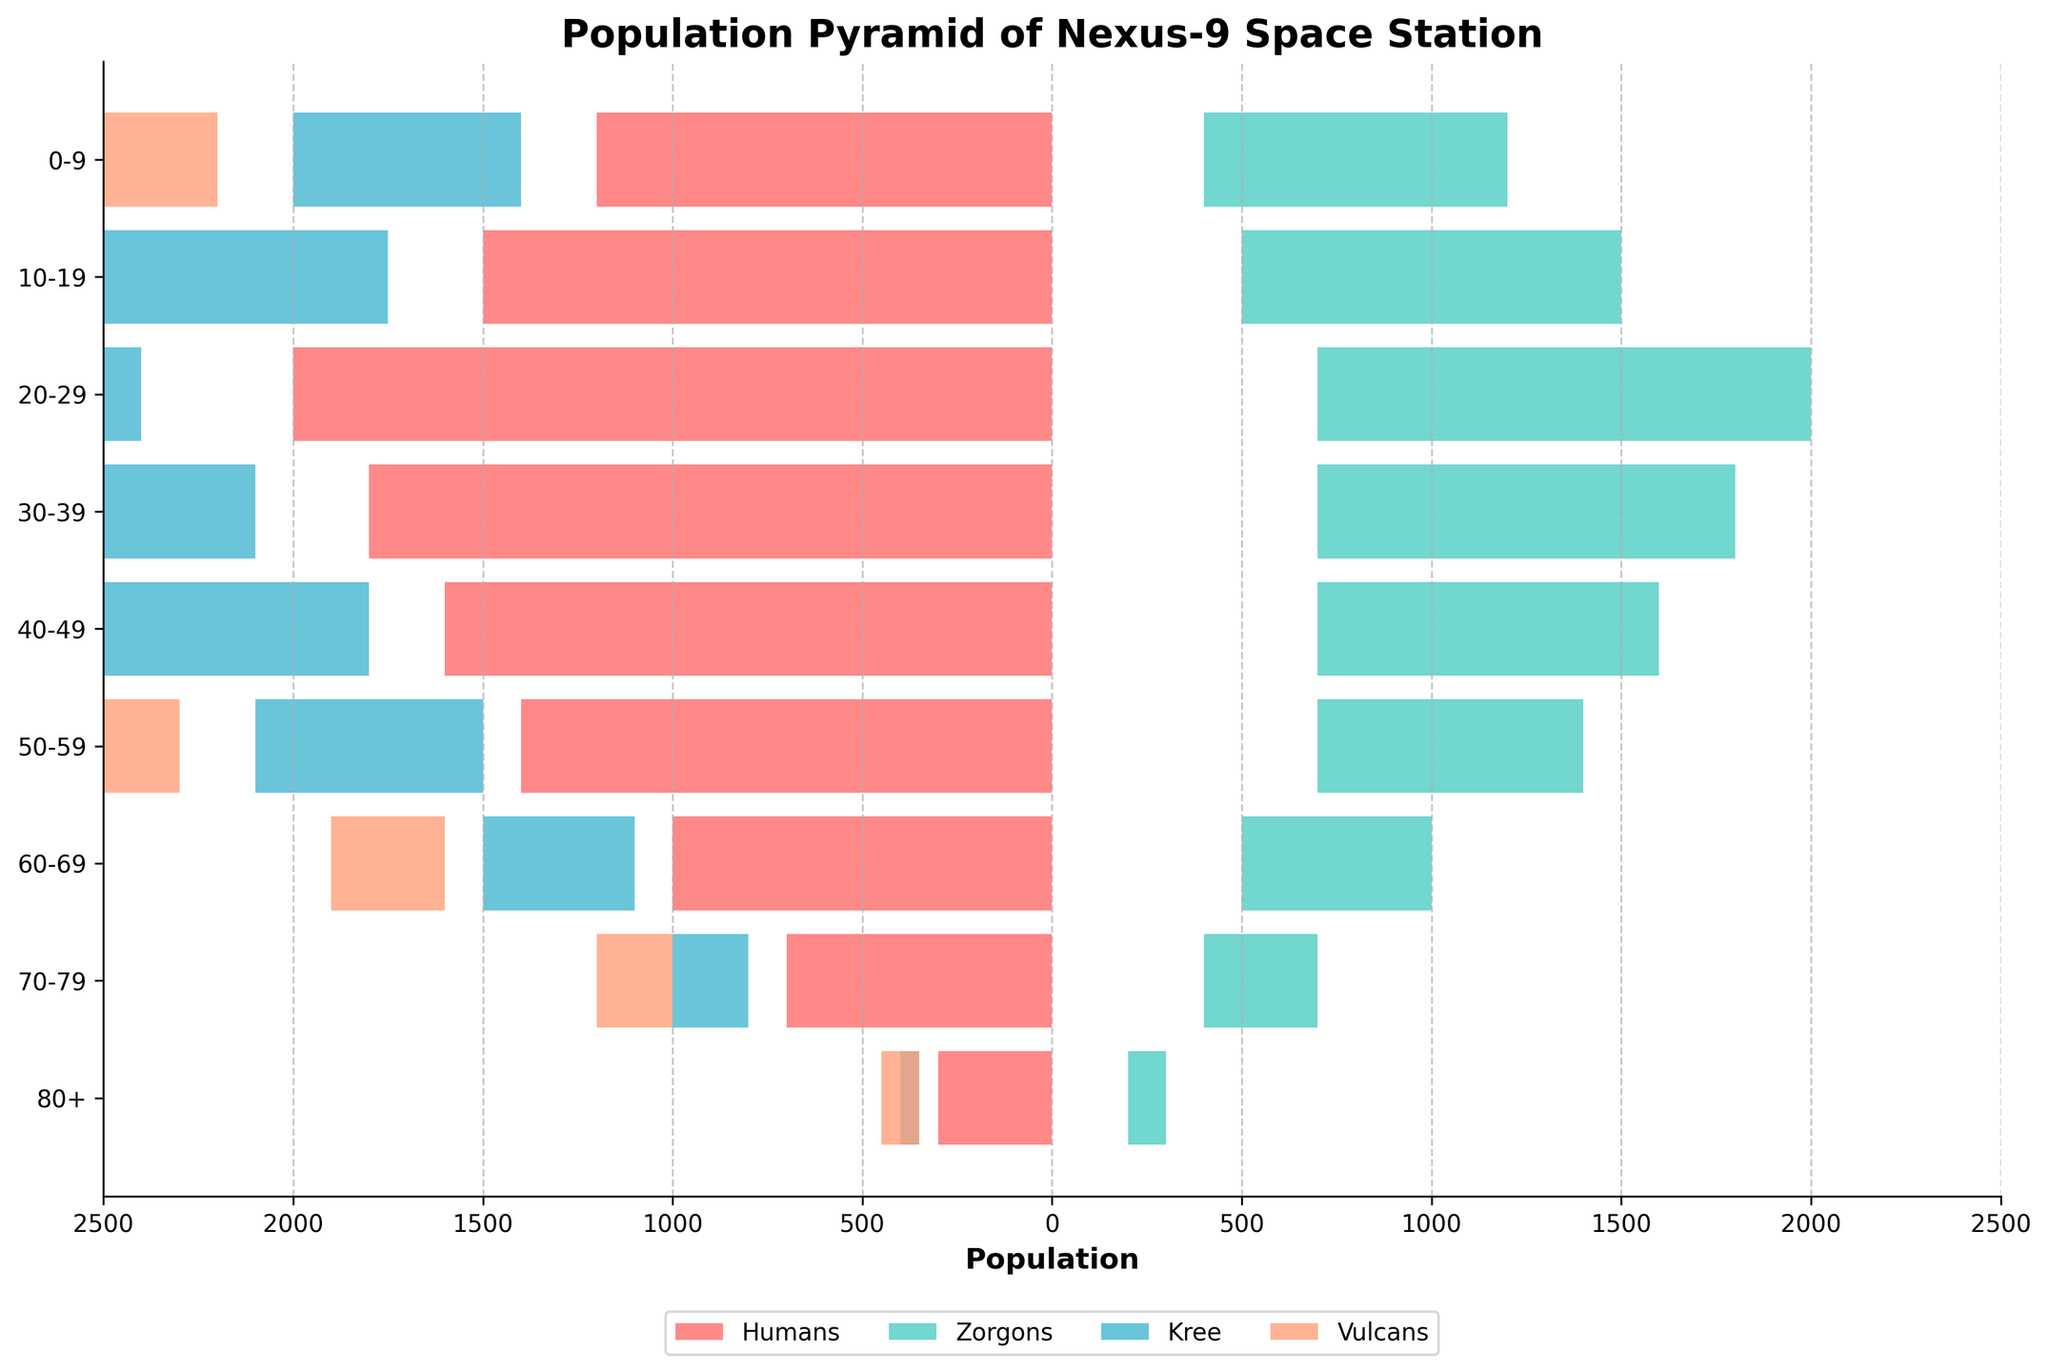How many age groups are represented in the pyramid? The y-axis shows the age groups, which are listed vertically. Counting the unique labels, there are 9 age groups present in the pyramid.
Answer: 9 What is the total population of Zorgons in the 20-29 age group? Referring to the bar segment for Zorgons in the 20-29 age group, the figure shows a value of 1300.
Answer: 1300 Which species has the smallest population in the 70-79 age group? Observing the lengths of the bars for each species in the 70-79 age group, the Kree have the smallest segment with a population of 200.
Answer: Kree What is the difference in population between Humans and Vulcans in the 40-49 age group? Referencing the bar lengths for Humans and Vulcans in the 40-49 age group, Humans have 1600 and Vulcans have 500. Subtracting these: 1600 - 500 = 1100.
Answer: 1100 Which age group has the highest combined population for Humans and Zorgons? By visually adding the segments for Humans and Zorgons in each age group, the 20-29 age group has the highest combined value: Humans (2000) + Zorgons (1300) = 3300.
Answer: 20-29 In which age group is the total number of Kree higher than the total number of Zorgons? Comparing the bar lengths for Kree and Zorgons across age groups, this occurs in the 80+ age group where Kree have 50 and Zorgons have 100 (no other age group fits this criterion).
Answer: None What is the percentage of the population that are Vulcans in the 50-59 age group? The total population for the 50-59 age group is the sum for all species: 1400 (Humans) + 700 (Zorgons) + 600 (Kree) + 400 (Vulcans) = 3100. The Vulcan population is 400. Thus, the percentage is (400/3100) * 100 ≈ 12.9%.
Answer: 12.9% How many more Zorgons than Kree are there in the 10-19 age group? Referring to the segments for Zorgons and Kree in the 10-19 age group, Zorgons have 1000 and Kree have 750. Subtracting these: 1000 - 750 = 250.
Answer: 250 Do humans have a decreasing population trend with increasing age groups? Observing the bar lengths for Humans across the age groups: 0-9 (1200), 10-19 (1500), 20-29 (2000), 30-39 (1800), 40-49 (1600), 50-59 (1400), 60-69 (1000), 70-79 (700), 80+ (300), there is an initial increase until 20-29, followed by a general decline.
Answer: Yes 